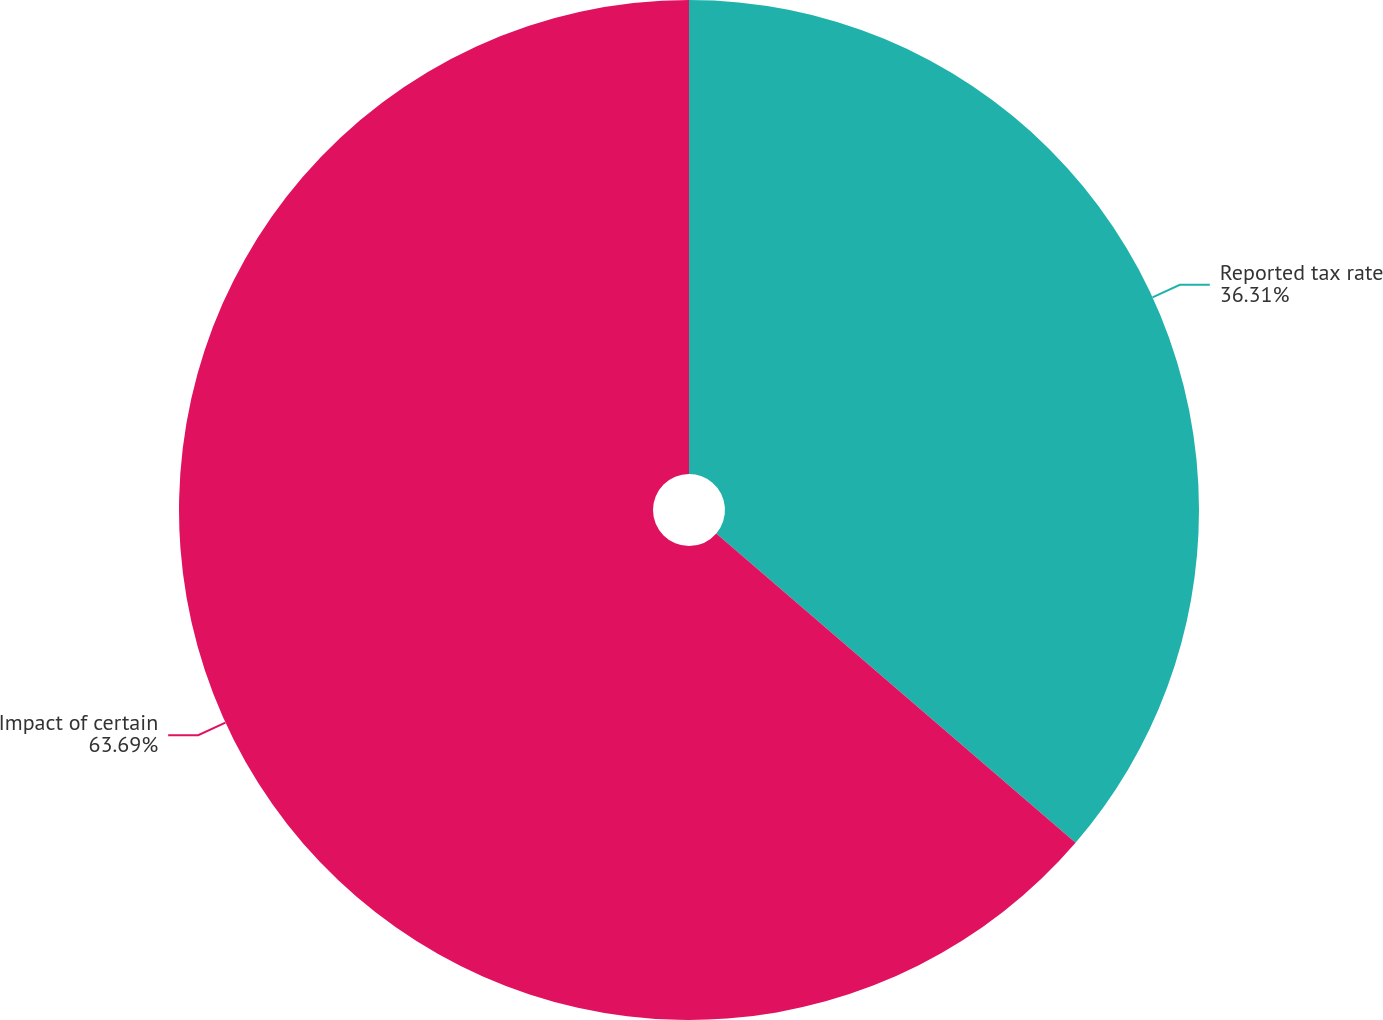<chart> <loc_0><loc_0><loc_500><loc_500><pie_chart><fcel>Reported tax rate<fcel>Impact of certain<nl><fcel>36.31%<fcel>63.69%<nl></chart> 